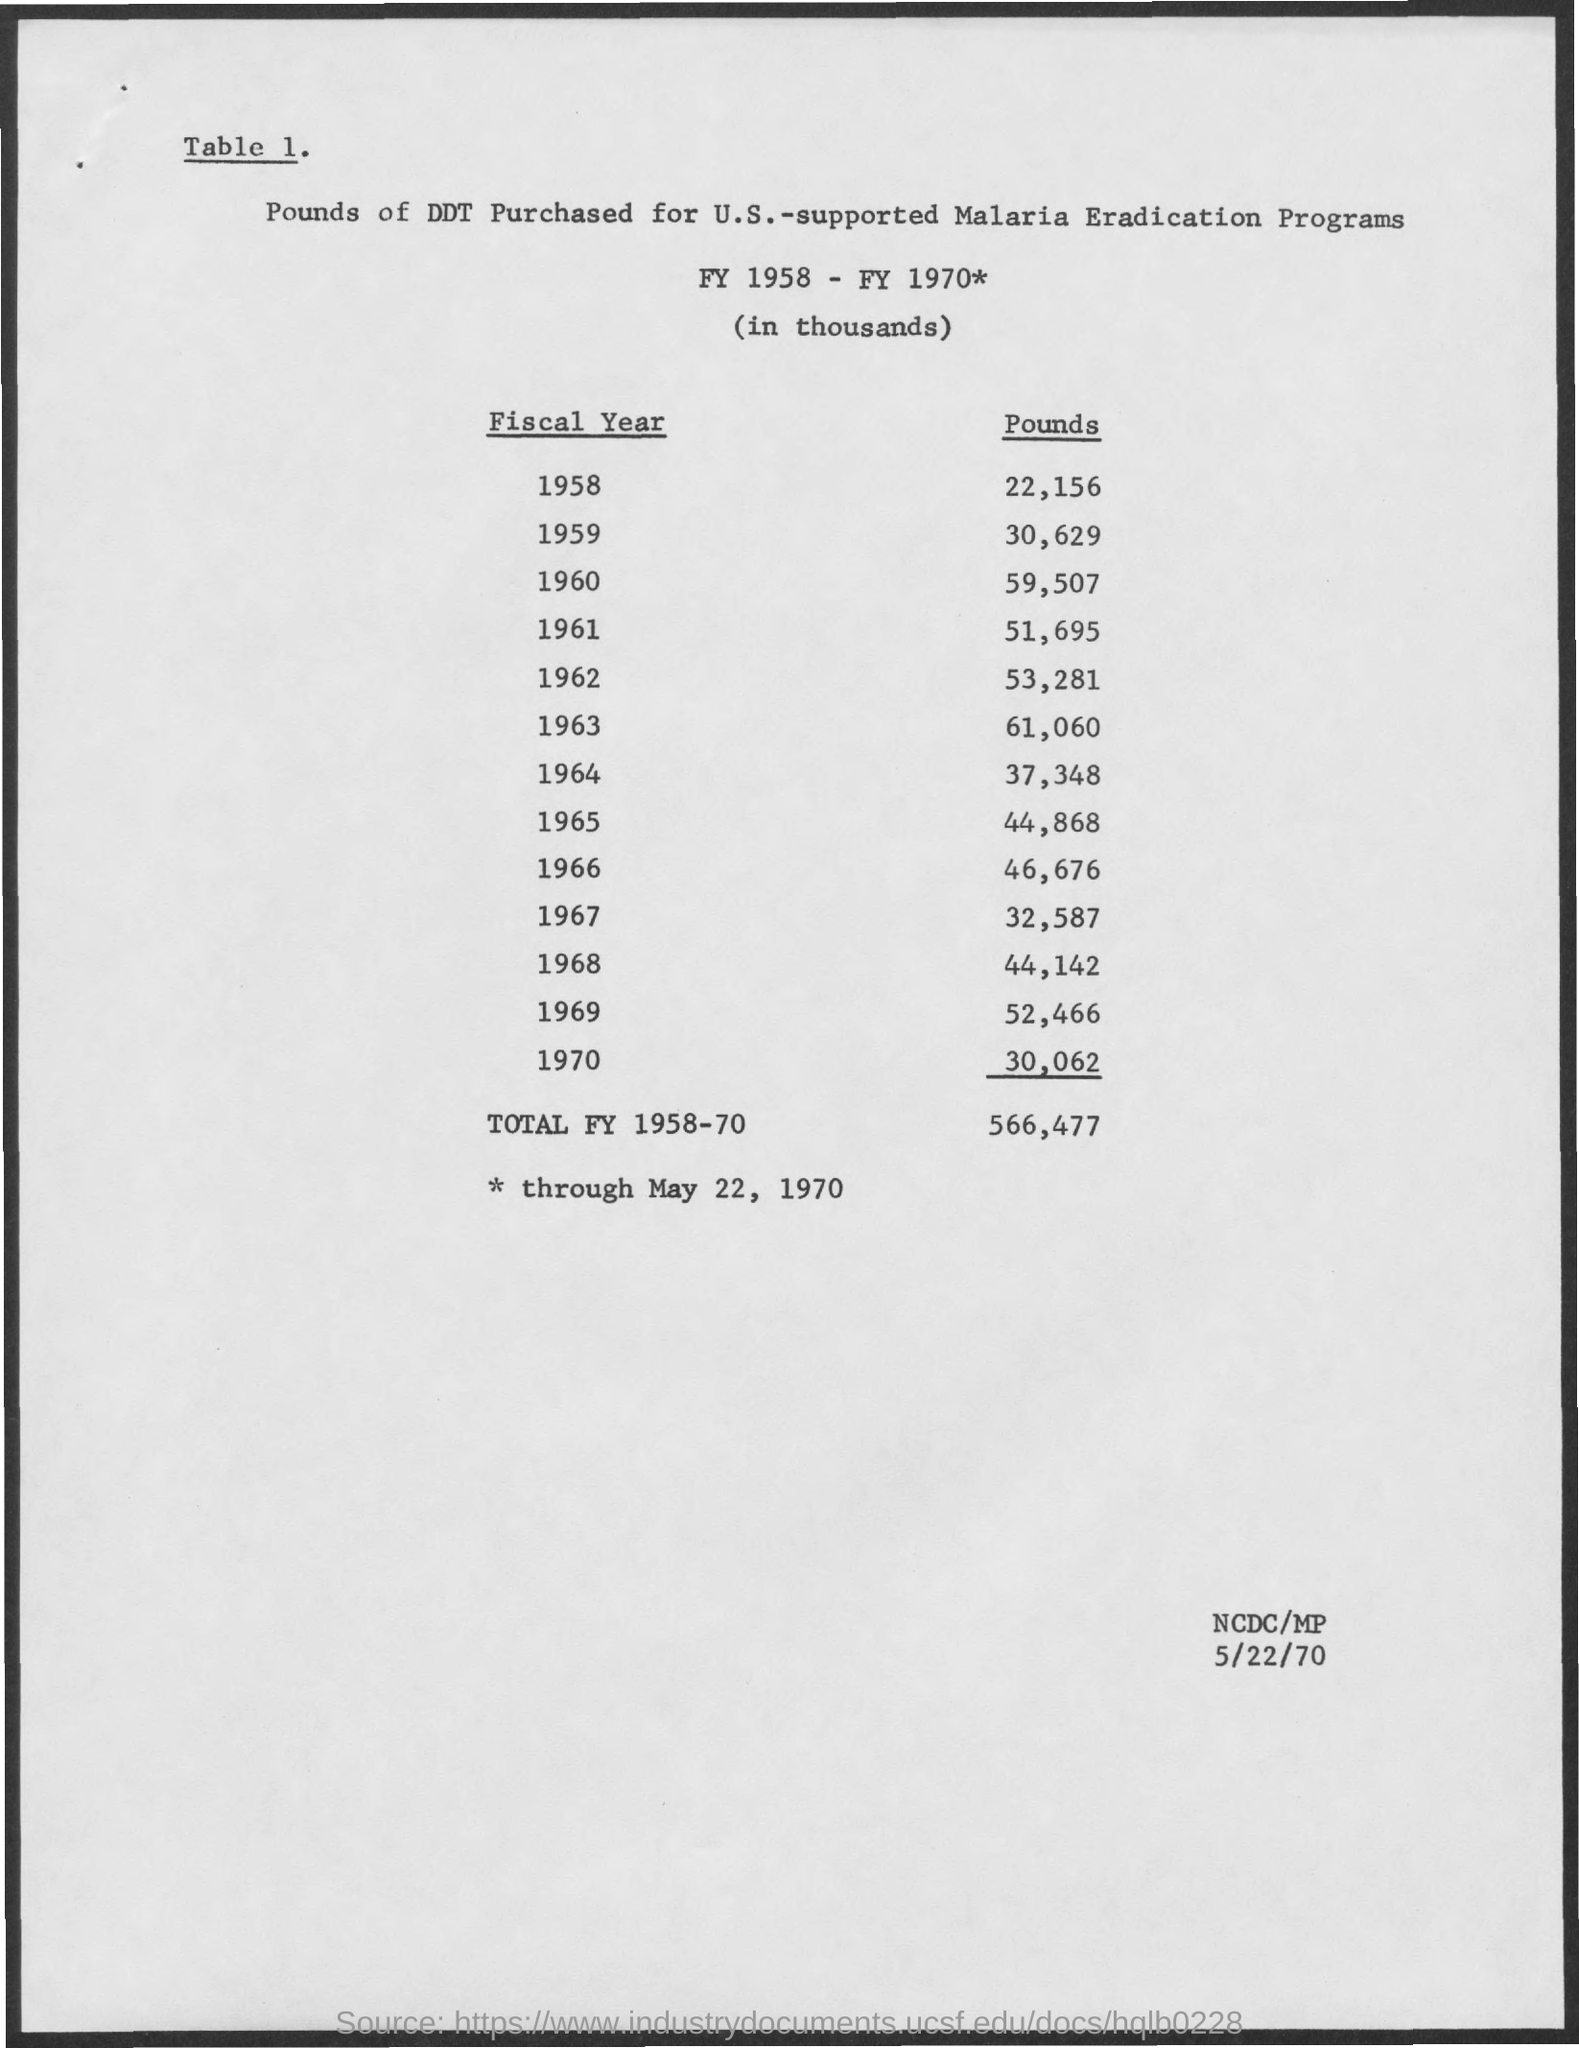Give some essential details in this illustration. What was purchased in pounds for U.S.? The total amount is DDT. The date mentioned in the bottom right corner is 5/22/70. During the fiscal year 1958, a total of 22,156 units of DDT were purchased. During the period of FY 1958-1970, a total of 566,477 units of DDT were purchased. 